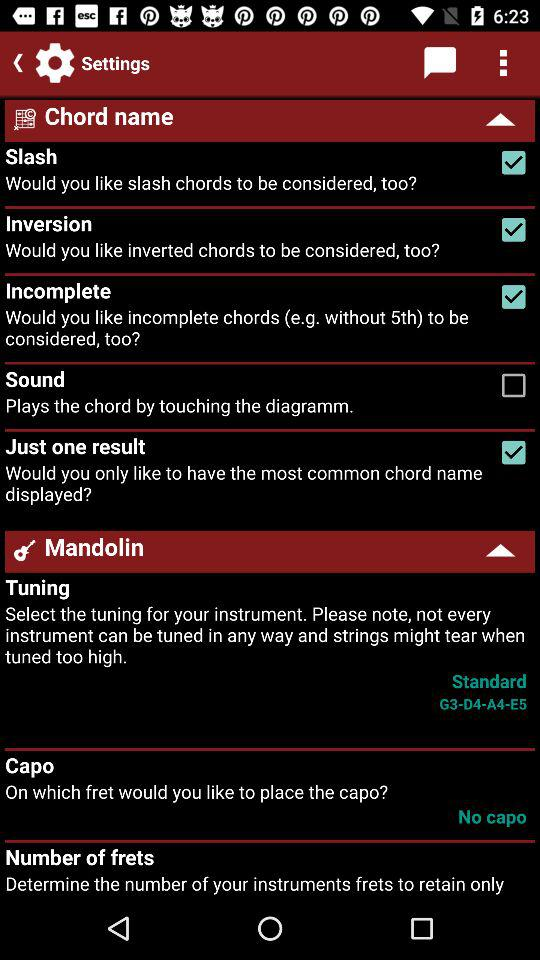What is the status of the capo?
When the provided information is insufficient, respond with <no answer>. <no answer> 